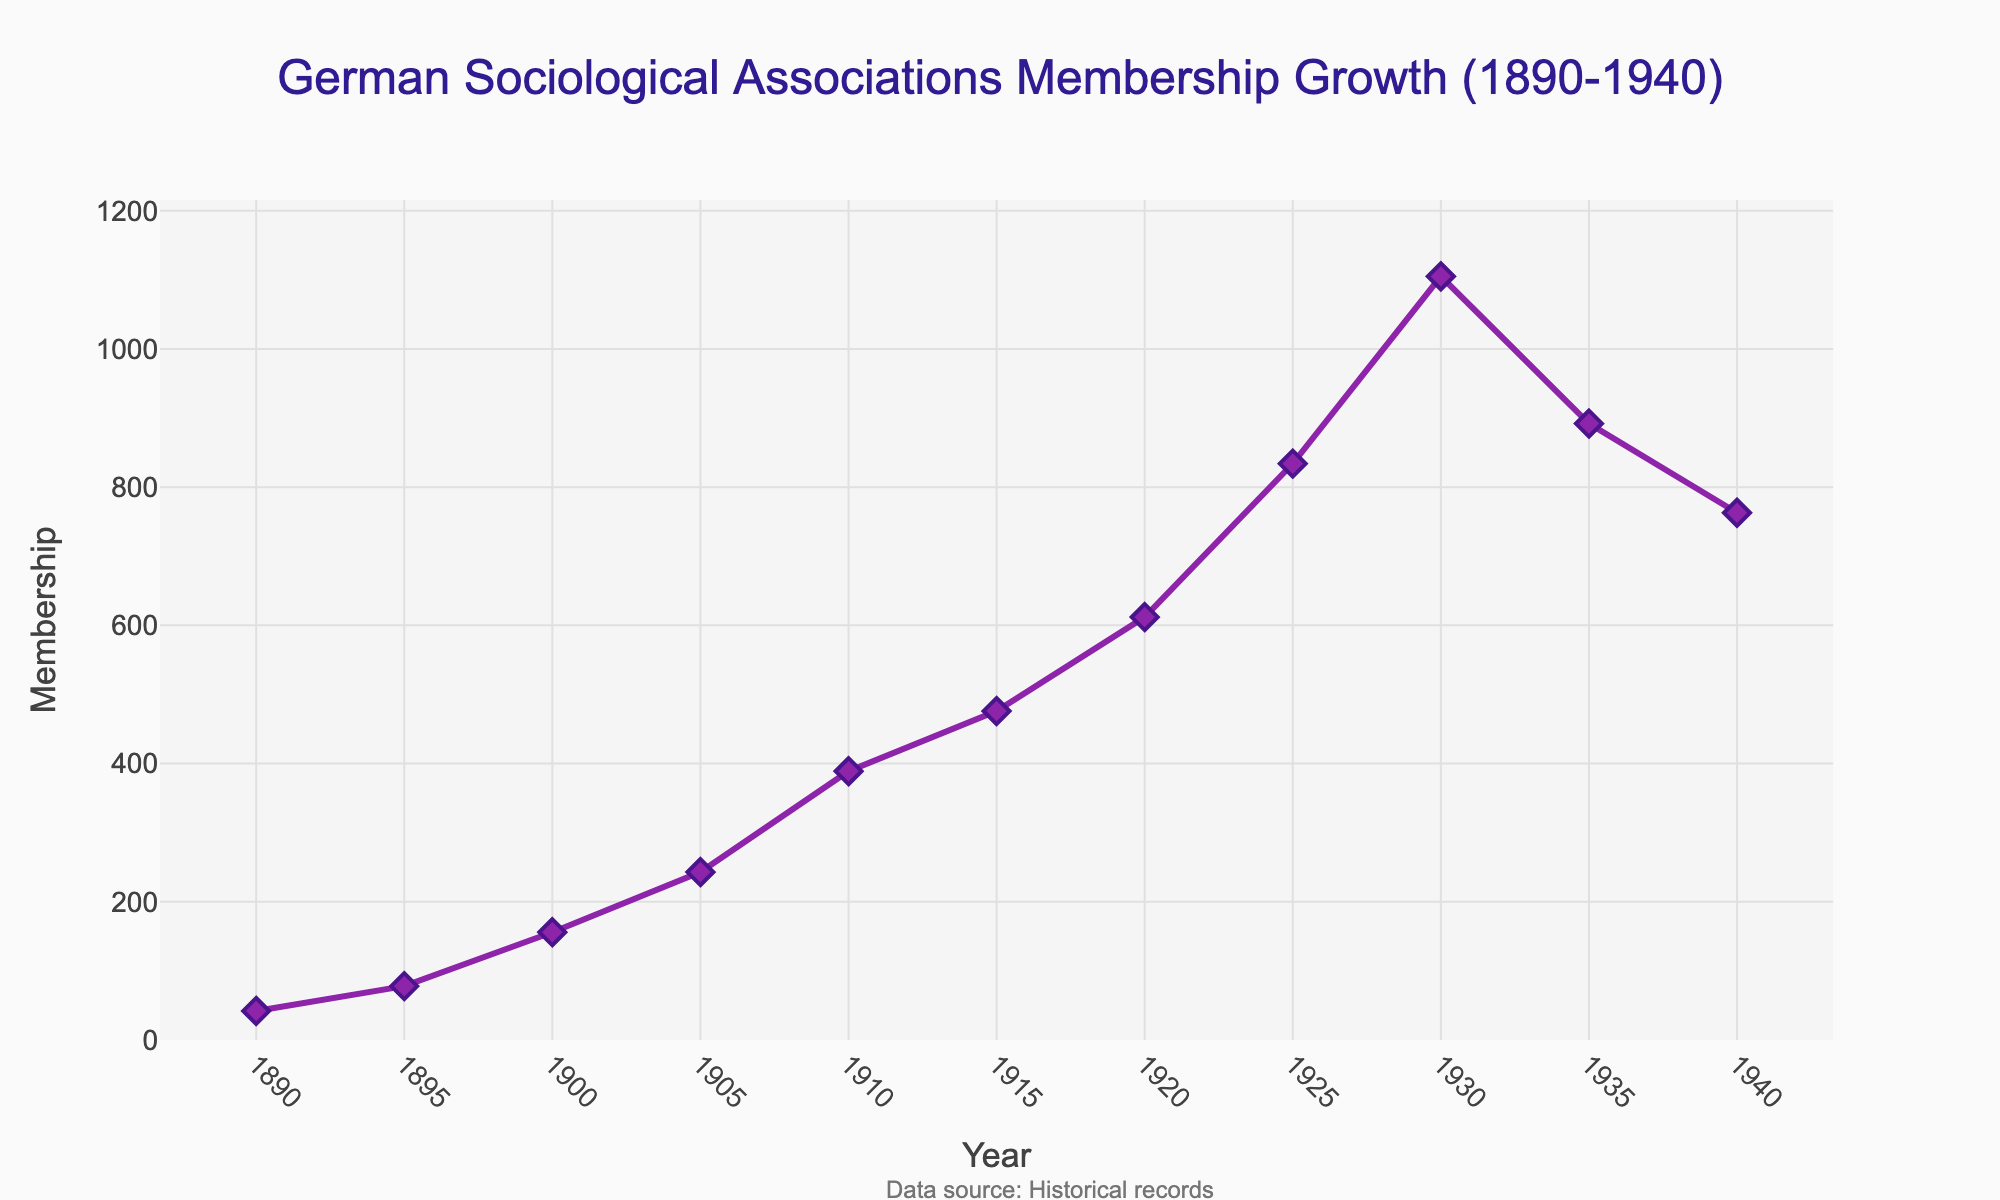What is the general trend of membership growth from 1890 to 1940? From 1890 to 1940, membership in German sociological associations generally increased, reaching a peak around 1930 before declining thereafter.
Answer: Increasing In which year did the membership reach its highest point according to the plot? By examining the plot, membership reached its highest point in 1930.
Answer: 1930 Which period saw the greatest increase in membership? By comparing the slopes of the line segments, the steepest increase appears between 1925 and 1930.
Answer: 1925-1930 What was the membership in 1935, and how does it compare to the membership in 1940? In 1935, the membership was 892, while in 1940 it was 763. So, the membership decreased by 129 from 1935 to 1940.
Answer: 1935: 892, 1940: 763, Decreased by 129 What is the difference in membership between 1910 and 1920? In 1910, the membership was 389, and in 1920, it was 612. So, the difference is 612 - 389 = 223.
Answer: 223 Around which year did membership growth start to decline? Observing the plot, membership growth started to decline after its peak around 1930.
Answer: After 1930 What is the approximate percentage increase in membership from 1890 to 1930? Initial membership in 1890 was 42, and in 1930 it was 1105. The percentage increase is ((1105 - 42) / 42) * 100 ≈ 2529.76%.
Answer: ≈ 2529.76% How does the membership number in 1910 compare to the membership number in 1900? In 1910, the membership was 389, compared to 156 in 1900. Therefore, it more than doubled.
Answer: More than doubled Which period experienced a membership decline, and by how much? The period from 1930 to 1940 experienced a decline, from 1105 in 1930 to 763 in 1940. The decline was 1105 - 763 = 342.
Answer: 1930-1940, decline by 342 What visual aspect of the plot indicates the highest level of membership growth? The steepest upward sloping segment of the line, especially between 1925 and 1930, visually indicates the highest level of membership growth.
Answer: Steepest upward slope 